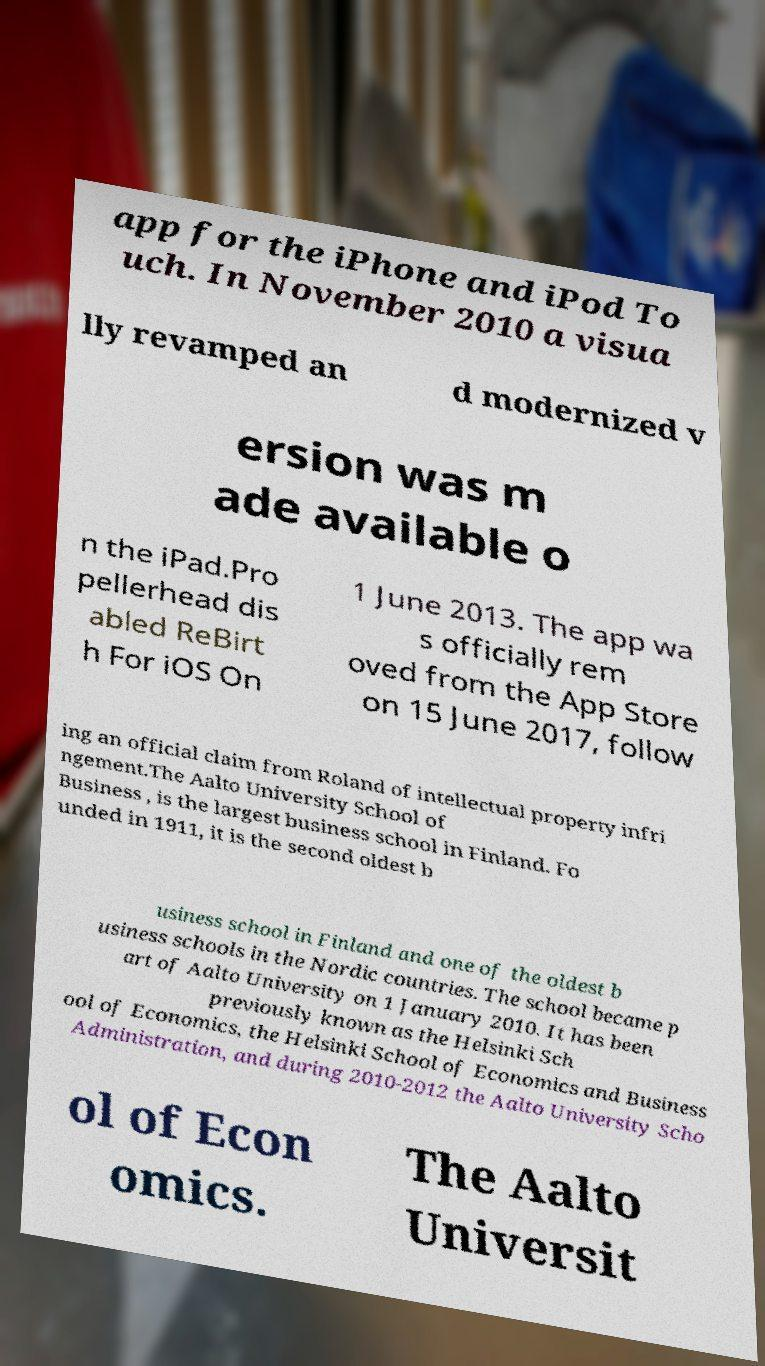There's text embedded in this image that I need extracted. Can you transcribe it verbatim? app for the iPhone and iPod To uch. In November 2010 a visua lly revamped an d modernized v ersion was m ade available o n the iPad.Pro pellerhead dis abled ReBirt h For iOS On 1 June 2013. The app wa s officially rem oved from the App Store on 15 June 2017, follow ing an official claim from Roland of intellectual property infri ngement.The Aalto University School of Business , is the largest business school in Finland. Fo unded in 1911, it is the second oldest b usiness school in Finland and one of the oldest b usiness schools in the Nordic countries. The school became p art of Aalto University on 1 January 2010. It has been previously known as the Helsinki Sch ool of Economics, the Helsinki School of Economics and Business Administration, and during 2010-2012 the Aalto University Scho ol of Econ omics. The Aalto Universit 